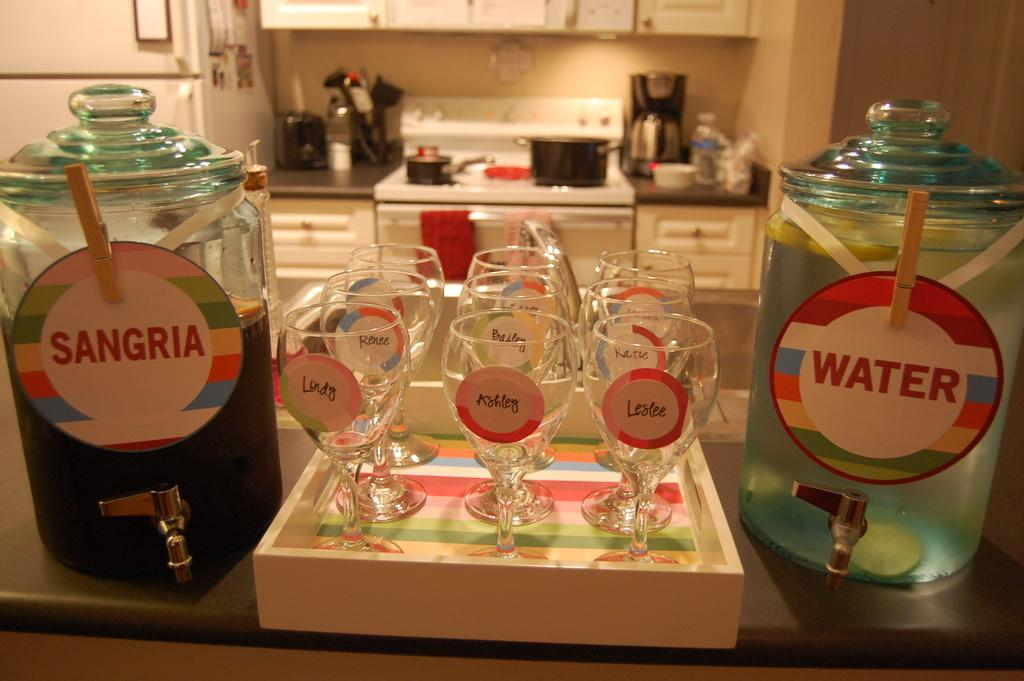<image>
Share a concise interpretation of the image provided. Six wine glasses on a serving tray between two glass beverage dispensers filled with water and Sangria. 